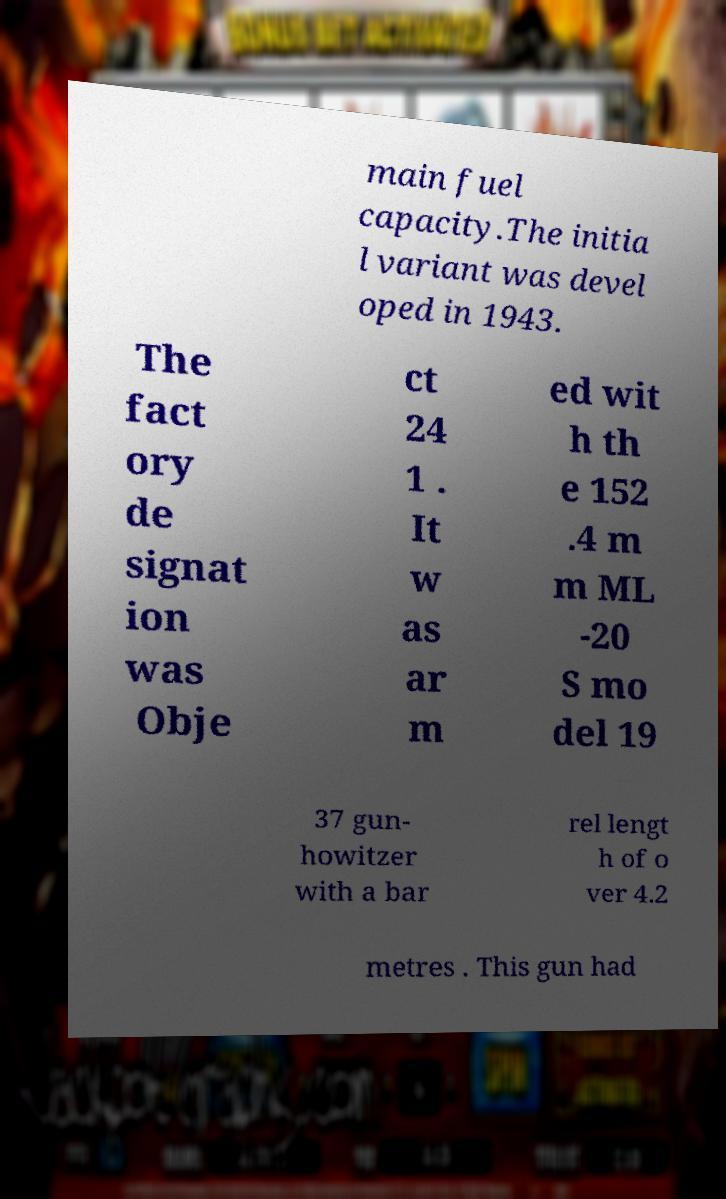Could you extract and type out the text from this image? main fuel capacity.The initia l variant was devel oped in 1943. The fact ory de signat ion was Obje ct 24 1 . It w as ar m ed wit h th e 152 .4 m m ML -20 S mo del 19 37 gun- howitzer with a bar rel lengt h of o ver 4.2 metres . This gun had 